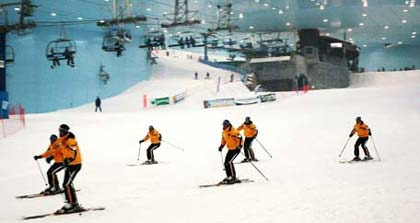Where is the ski lift located in relation to the skiers? The ski lift is situated in the background, behind the skiers. It's elevated above the slope, and you can see several chairs moving along its line, likely carrying more people up the slope. 